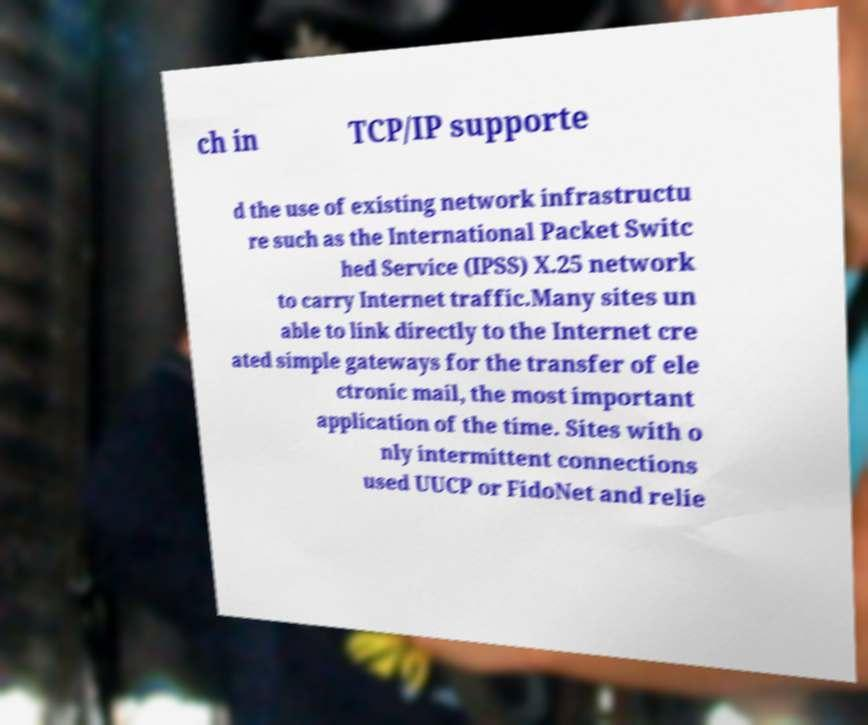Please identify and transcribe the text found in this image. ch in TCP/IP supporte d the use of existing network infrastructu re such as the International Packet Switc hed Service (IPSS) X.25 network to carry Internet traffic.Many sites un able to link directly to the Internet cre ated simple gateways for the transfer of ele ctronic mail, the most important application of the time. Sites with o nly intermittent connections used UUCP or FidoNet and relie 